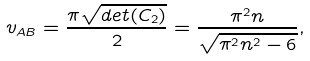Convert formula to latex. <formula><loc_0><loc_0><loc_500><loc_500>v _ { A B } = \frac { \pi \sqrt { d e t ( C _ { 2 } ) } } { 2 } = \frac { \pi ^ { 2 } n } { \sqrt { \pi ^ { 2 } n ^ { 2 } - 6 } } ,</formula> 